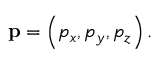<formula> <loc_0><loc_0><loc_500><loc_500>p = \left ( p _ { x } , p _ { y } , p _ { z } \right ) .</formula> 